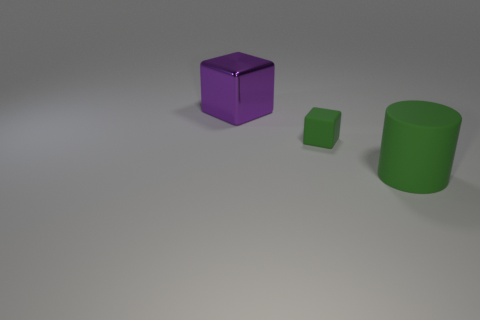Is there any other thing that has the same material as the purple object?
Offer a very short reply. No. The object behind the block in front of the large purple cube is what color?
Your answer should be very brief. Purple. There is a rubber cylinder that is the same color as the small block; what size is it?
Keep it short and to the point. Large. There is a large object that is in front of the big purple block to the left of the green cylinder; how many matte blocks are behind it?
Offer a terse response. 1. There is a large object behind the tiny green rubber cube; is it the same shape as the green object left of the green cylinder?
Make the answer very short. Yes. How many things are yellow metallic things or cylinders?
Keep it short and to the point. 1. The object that is in front of the block in front of the big purple shiny cube is made of what material?
Give a very brief answer. Rubber. Is there a object of the same color as the large shiny block?
Your answer should be compact. No. There is a matte cylinder that is the same size as the purple shiny cube; what is its color?
Make the answer very short. Green. What material is the block on the right side of the thing that is on the left side of the cube in front of the big purple cube?
Your answer should be very brief. Rubber. 